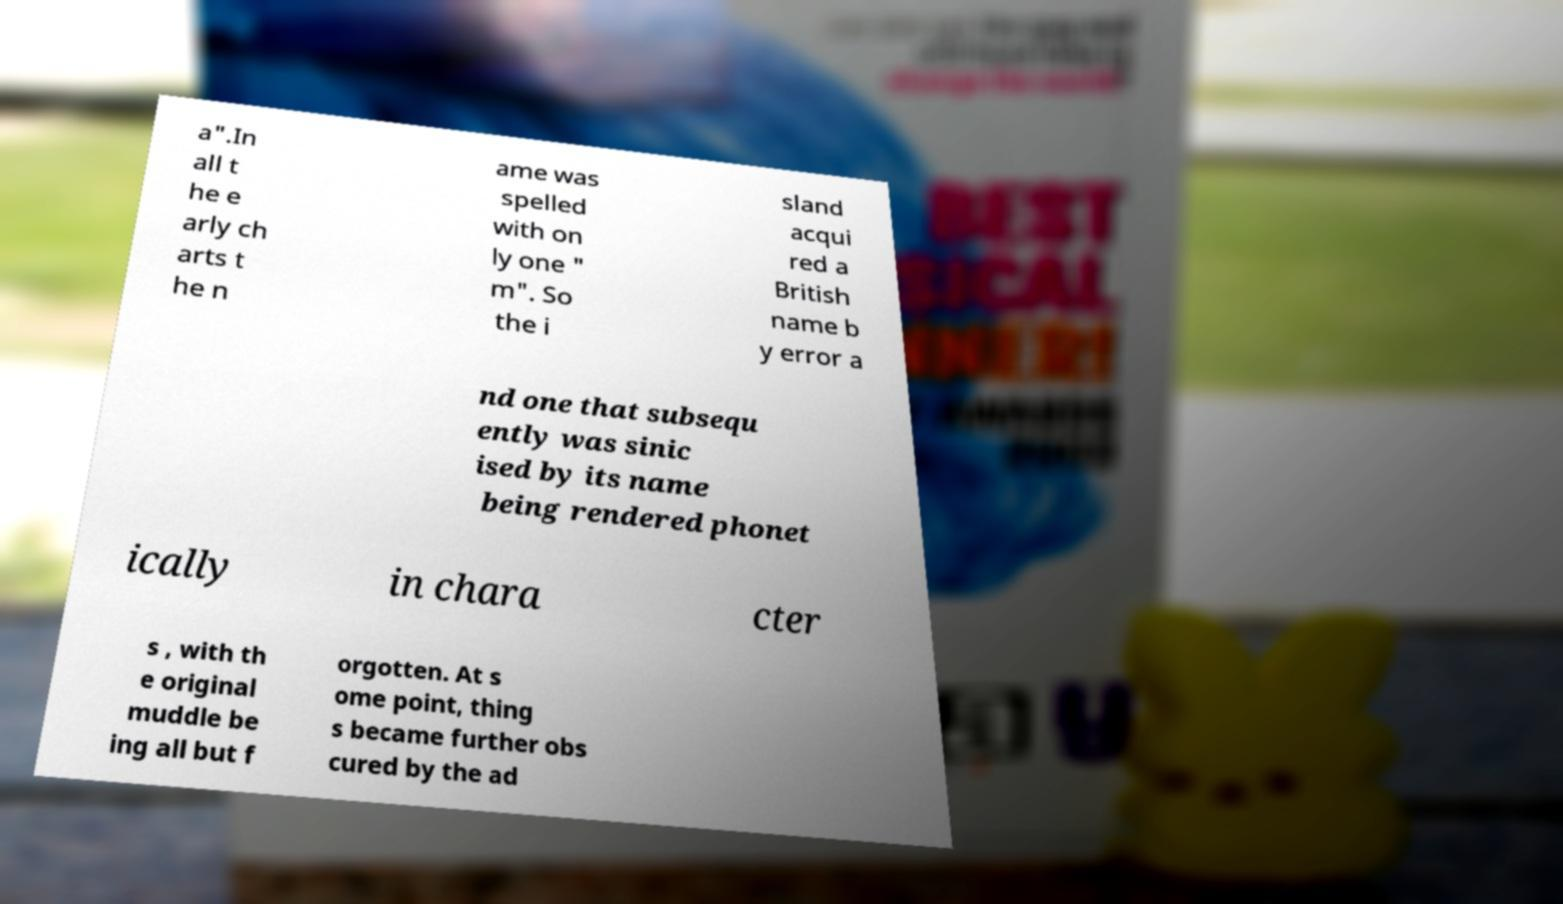Please identify and transcribe the text found in this image. a".In all t he e arly ch arts t he n ame was spelled with on ly one " m". So the i sland acqui red a British name b y error a nd one that subsequ ently was sinic ised by its name being rendered phonet ically in chara cter s , with th e original muddle be ing all but f orgotten. At s ome point, thing s became further obs cured by the ad 